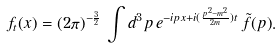<formula> <loc_0><loc_0><loc_500><loc_500>f _ { t } ( x ) = ( 2 \pi ) ^ { - \frac { 3 } { 2 } } \, \int d ^ { 3 } p \, e ^ { - i p x + i ( \frac { p ^ { 2 } - m ^ { 2 } } { 2 m } ) t } \, \tilde { f } ( p ) .</formula> 